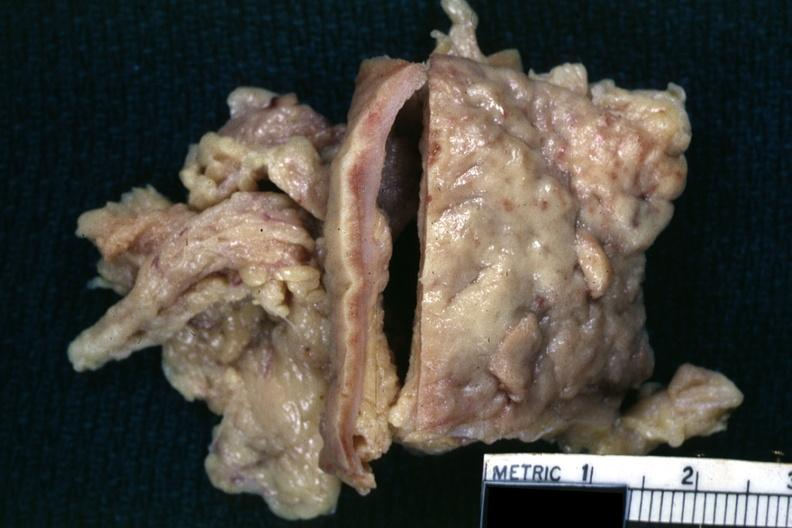does this image show fixed tissue?
Answer the question using a single word or phrase. Yes 